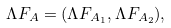<formula> <loc_0><loc_0><loc_500><loc_500>\Lambda F _ { A } = ( \Lambda F _ { A _ { 1 } } , \Lambda F _ { A _ { 2 } } ) ,</formula> 